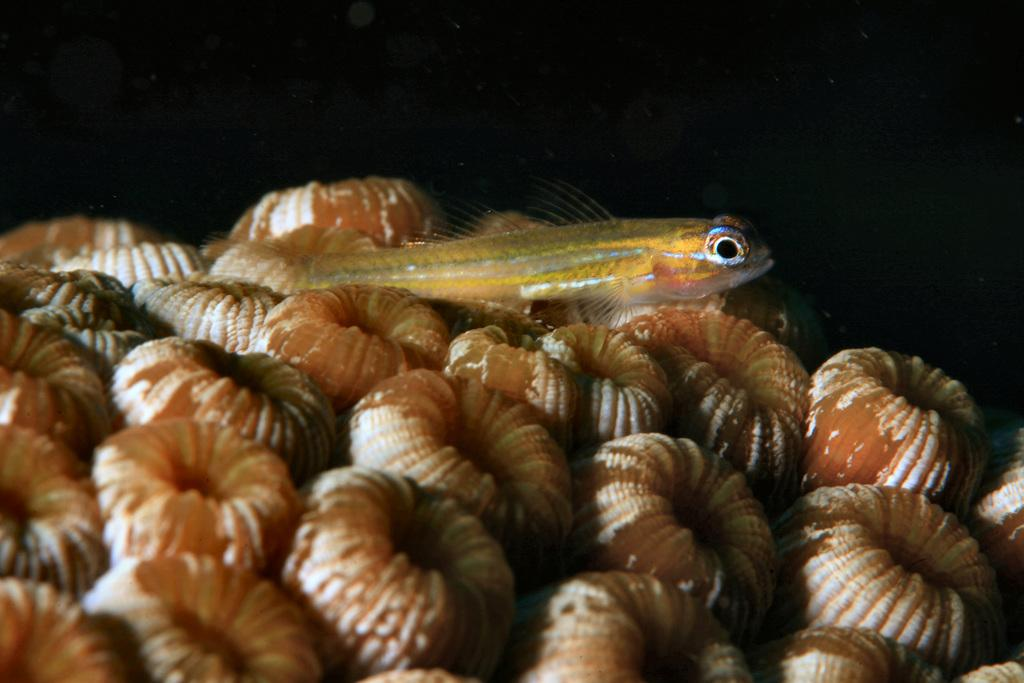What type of objects are present in the image? There are many round-shaped shells in the image. Can you identify any living creatures in the image? Yes, there is a fish in the image. What type of cattle can be seen grazing in the image? There is no cattle present in the image; it features many round-shaped shells and a fish. What type of pan is being used to cook the fish in the image? There is no pan or cooking activity present in the image. 